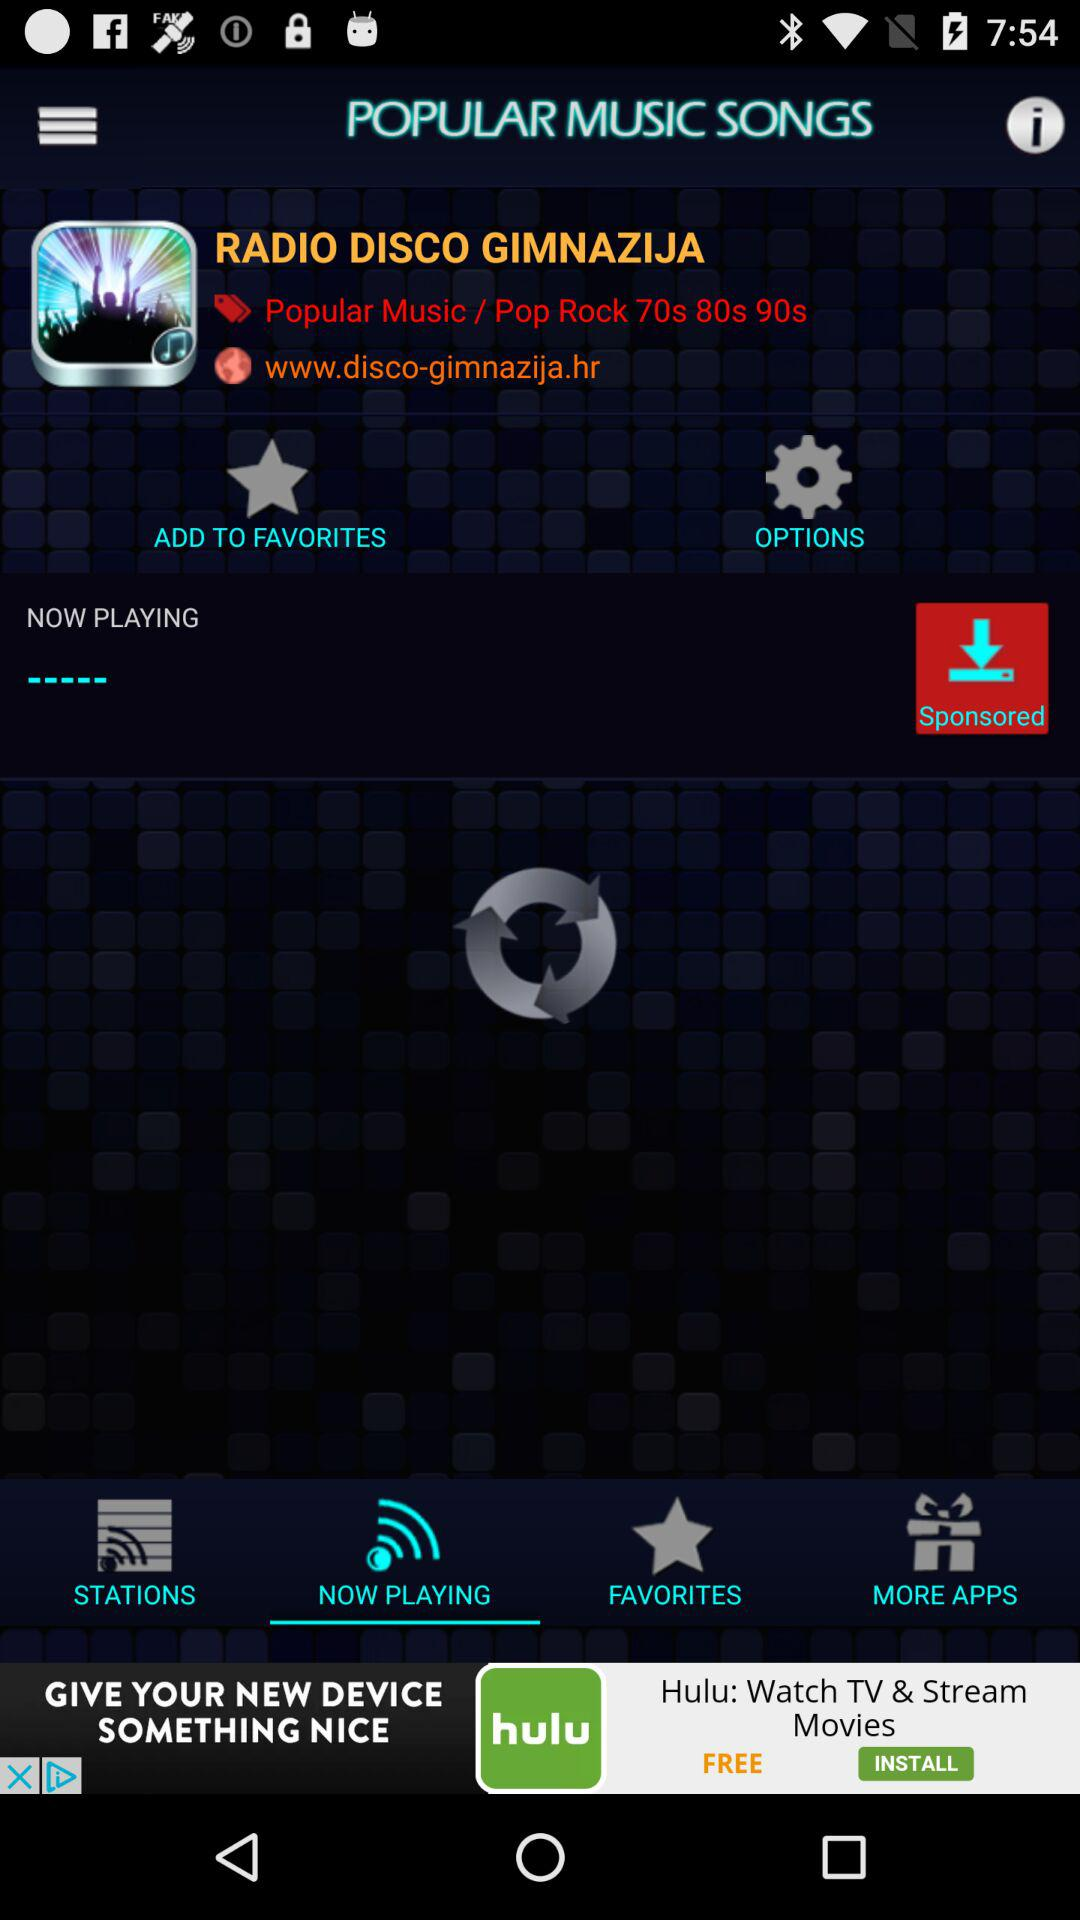What is the website if I want to visit "RADIO DISCO GIMNAZIJA"? The website is www.disco-gimnazija.hr. 